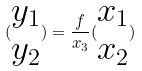<formula> <loc_0><loc_0><loc_500><loc_500>( \begin{matrix} y _ { 1 } \\ y _ { 2 } \end{matrix} ) = \frac { f } { x _ { 3 } } ( \begin{matrix} x _ { 1 } \\ x _ { 2 } \end{matrix} )</formula> 